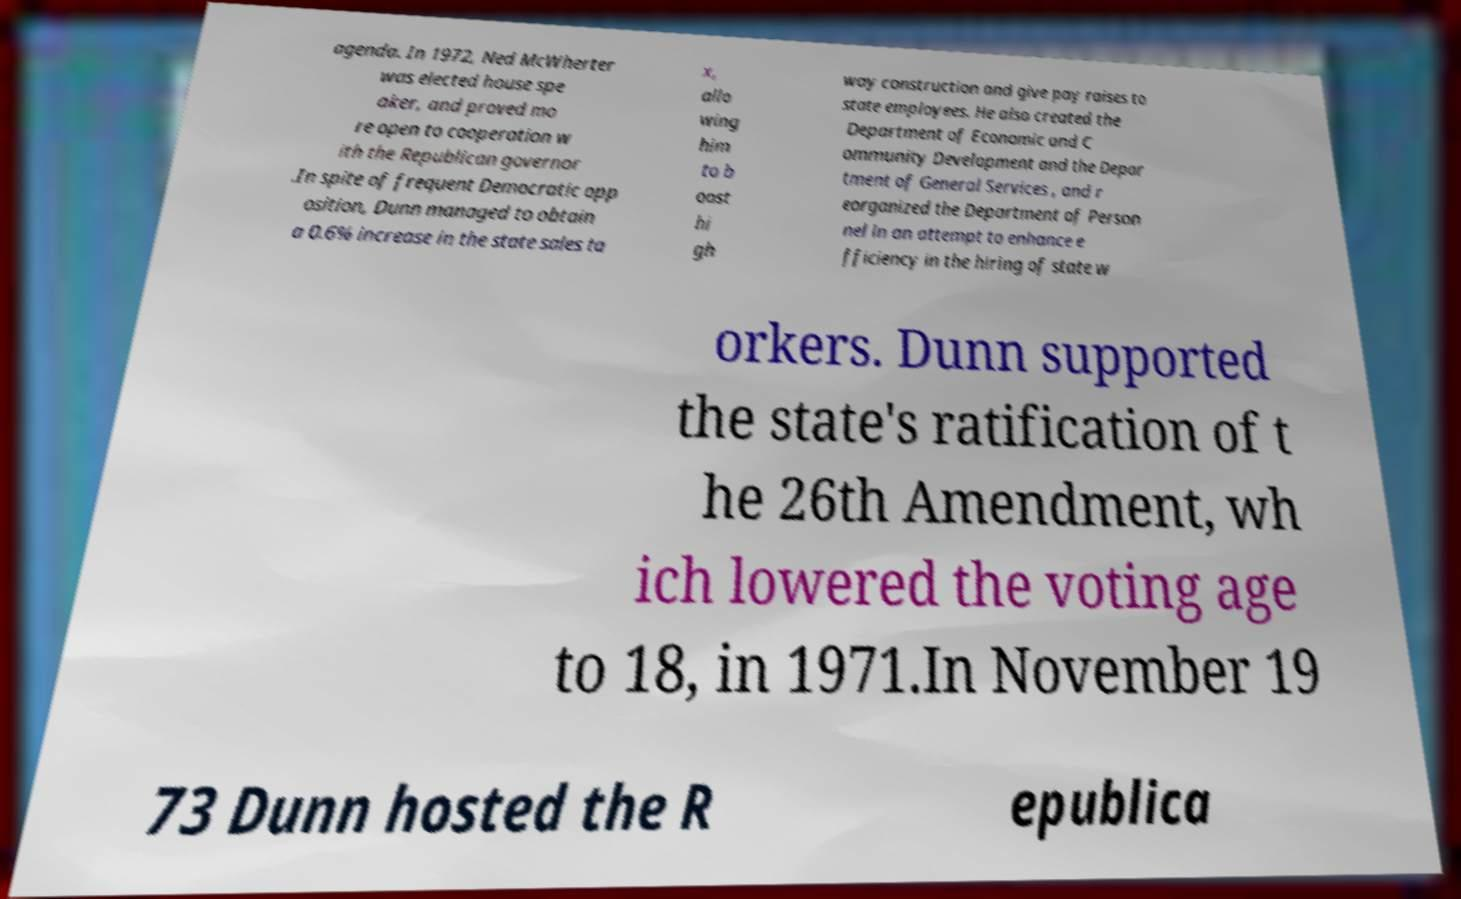Could you extract and type out the text from this image? agenda. In 1972, Ned McWherter was elected house spe aker, and proved mo re open to cooperation w ith the Republican governor .In spite of frequent Democratic opp osition, Dunn managed to obtain a 0.6% increase in the state sales ta x, allo wing him to b oost hi gh way construction and give pay raises to state employees. He also created the Department of Economic and C ommunity Development and the Depar tment of General Services , and r eorganized the Department of Person nel in an attempt to enhance e fficiency in the hiring of state w orkers. Dunn supported the state's ratification of t he 26th Amendment, wh ich lowered the voting age to 18, in 1971.In November 19 73 Dunn hosted the R epublica 